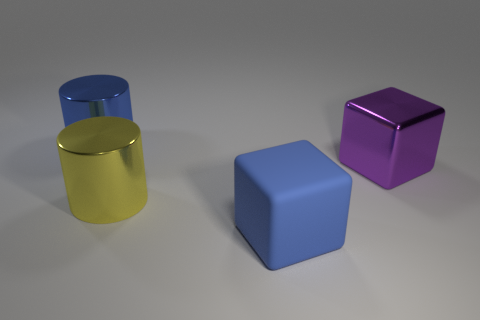Subtract all yellow cylinders. How many cylinders are left? 1 Add 2 big purple things. How many objects exist? 6 Subtract 1 cylinders. How many cylinders are left? 1 Subtract all tiny brown metal balls. Subtract all large matte cubes. How many objects are left? 3 Add 3 large blue blocks. How many large blue blocks are left? 4 Add 1 yellow blocks. How many yellow blocks exist? 1 Subtract 0 cyan balls. How many objects are left? 4 Subtract all cyan cylinders. Subtract all yellow blocks. How many cylinders are left? 2 